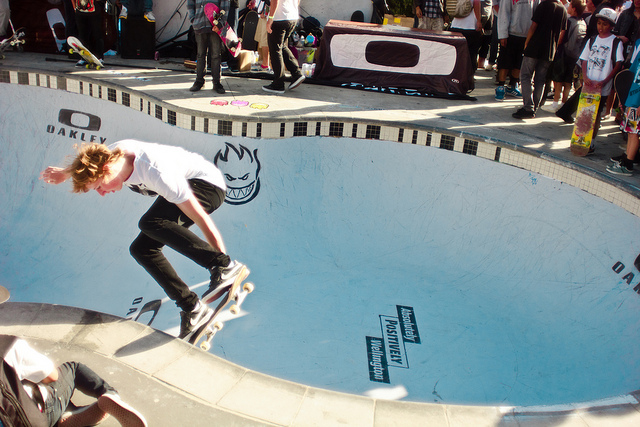Extract all visible text content from this image. DAKLEY QA Wellington POSITIVELY Absolutely OA O 